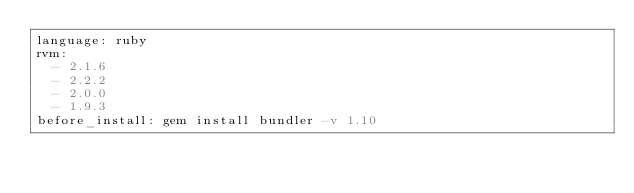Convert code to text. <code><loc_0><loc_0><loc_500><loc_500><_YAML_>language: ruby
rvm:
  - 2.1.6
  - 2.2.2
  - 2.0.0
  - 1.9.3
before_install: gem install bundler -v 1.10
</code> 